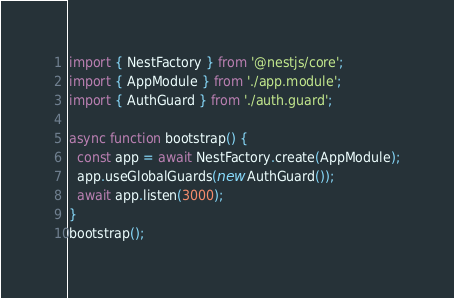<code> <loc_0><loc_0><loc_500><loc_500><_TypeScript_>import { NestFactory } from '@nestjs/core';
import { AppModule } from './app.module';
import { AuthGuard } from './auth.guard';

async function bootstrap() {
  const app = await NestFactory.create(AppModule);
  app.useGlobalGuards(new AuthGuard());
  await app.listen(3000);
}
bootstrap();
</code> 